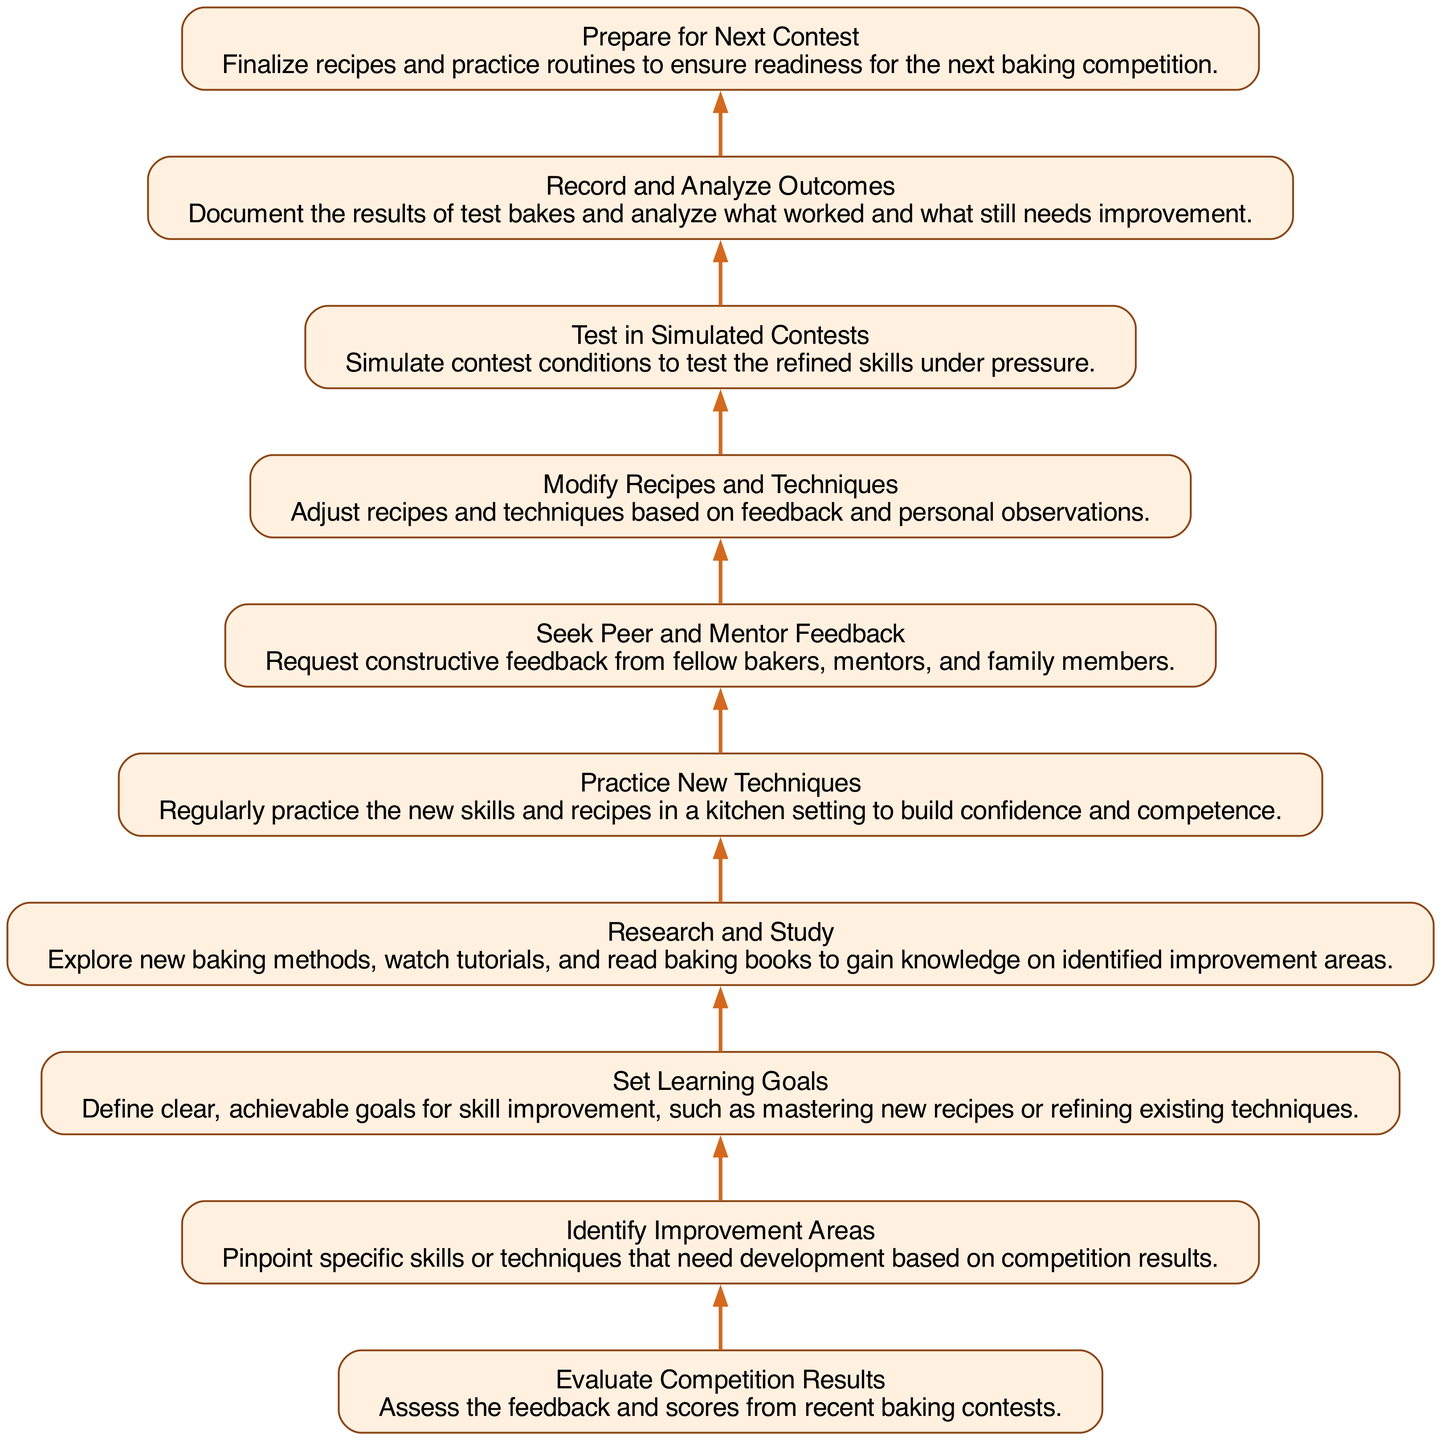What is the first step in the process? The first step in the process, as indicated at the bottom of the flowchart, is "Evaluate Competition Results". This is where bakers assess their previous baking contest outcomes and gather feedback.
Answer: Evaluate Competition Results How many steps are in the diagram? By counting the elements in the flowchart, there are a total of ten steps that outline the process to analyze and improve baking skills.
Answer: Ten steps Which step follows "Research and Study"? The step that follows "Research and Study" is "Practice New Techniques". This indicates that after gaining knowledge, the next action is to implement those learnings in practice.
Answer: Practice New Techniques What is the purpose of the "Seek Peer and Mentor Feedback" step? The purpose of this step is to gather constructive feedback from others, which helps to identify areas for further improvement based on the baker's trials.
Answer: To gather feedback Which two steps are connected by an edge without any intervening steps? The steps "Record and Analyze Outcomes" and "Prepare for Next Contest" are directly connected, indicating that after analyzing test results, preparation for the next competition begins immediately.
Answer: Record and Analyze Outcomes, Prepare for Next Contest What is the relationship between "Identify Improvement Areas" and "Set Learning Goals"? "Identify Improvement Areas" is the predecessor of "Set Learning Goals". This indicates that before setting goals, bakers must first determine which areas require improvement based on competition feedback.
Answer: Sequential relationship: Identify Improvement Areas -> Set Learning Goals How does the process depict the flow from one step to another? The flowchart visually represents the process with directed edges, showing a clear path from each step to the next in a bottom-to-up direction, indicating progression through the baking improvement steps.
Answer: Directed edges indicate progression What is the last step before "Prepare for Next Contest"? The step before "Prepare for Next Contest" is "Modify Recipes and Techniques". This indicates that bakers should make adjustments based on the outcomes from testing before finalizing their preparation for competitions.
Answer: Modify Recipes and Techniques Which step involves skill practice in a kitchen setting? The step that involves practicing skills in a kitchen setting is "Practice New Techniques". This step emphasizes hands-on experience to build confidence in new skills learned.
Answer: Practice New Techniques 